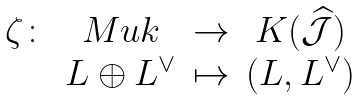<formula> <loc_0><loc_0><loc_500><loc_500>\begin{matrix} \zeta \colon & M u k & \rightarrow & K ( \widehat { \mathcal { J } } ) \\ & L \oplus L ^ { \vee } & \mapsto & ( L , L ^ { \vee } ) \\ \end{matrix}</formula> 